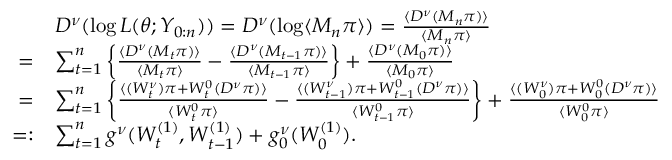Convert formula to latex. <formula><loc_0><loc_0><loc_500><loc_500>\begin{array} { r l } & { D ^ { \nu } ( \log L ( \theta ; Y _ { 0 \colon n } ) ) = D ^ { \nu } ( \log \langle M _ { n } \pi \rangle ) = \frac { \langle D ^ { \nu } ( M _ { n } \pi ) \rangle } { \langle M _ { n } \pi \rangle } } \\ { = } & { \sum _ { t = 1 } ^ { n } \left \{ \frac { \langle D ^ { \nu } ( M _ { t } \pi ) \rangle } { \langle M _ { t } \pi \rangle } - \frac { \langle D ^ { \nu } ( M _ { t - 1 } \pi ) \rangle } { \langle M _ { t - 1 } \pi \rangle } \right \} + \frac { \langle D ^ { \nu } ( M _ { 0 } \pi ) \rangle } { \langle M _ { 0 } \pi \rangle } } \\ { = } & { \sum _ { t = 1 } ^ { n } \left \{ \frac { \langle ( W _ { t } ^ { \nu } ) \pi + W _ { t } ^ { 0 } ( D ^ { \nu } \pi ) \rangle } { \langle W _ { t } ^ { 0 } \pi \rangle } - \frac { \langle ( W _ { t - 1 } ^ { \nu } ) \pi + W _ { t - 1 } ^ { 0 } ( D ^ { \nu } \pi ) \rangle } { \langle W _ { t - 1 } ^ { 0 } \pi \rangle } \right \} + \frac { \langle ( W _ { 0 } ^ { \nu } ) \pi + W _ { 0 } ^ { 0 } ( D ^ { \nu } \pi ) \rangle } { \langle W _ { 0 } ^ { 0 } \pi \rangle } } \\ { = \colon } & { \sum _ { t = 1 } ^ { n } g ^ { \nu } ( W _ { t } ^ { ( 1 ) } , W _ { t - 1 } ^ { ( 1 ) } ) + g _ { 0 } ^ { \nu } ( W _ { 0 } ^ { ( 1 ) } ) . } \end{array}</formula> 